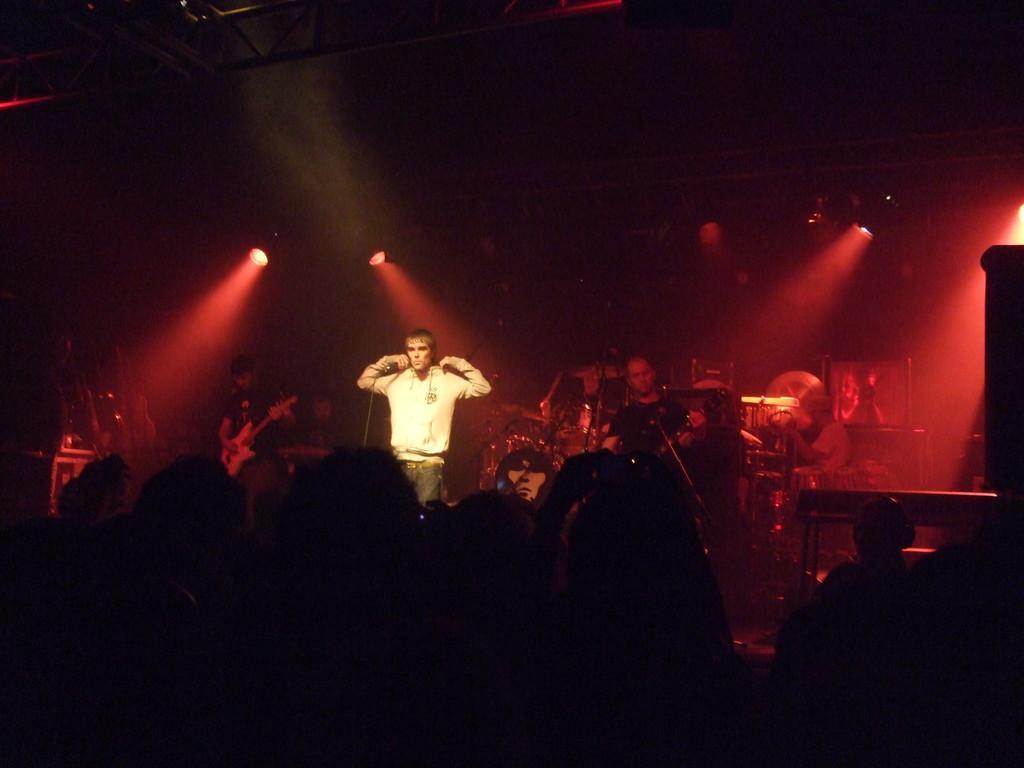Could you give a brief overview of what you see in this image? There is concert going on. A man in the middle with a hoodie and light focusing on him and many musicians in the background playing guitar and drums and there are people looking at them. 